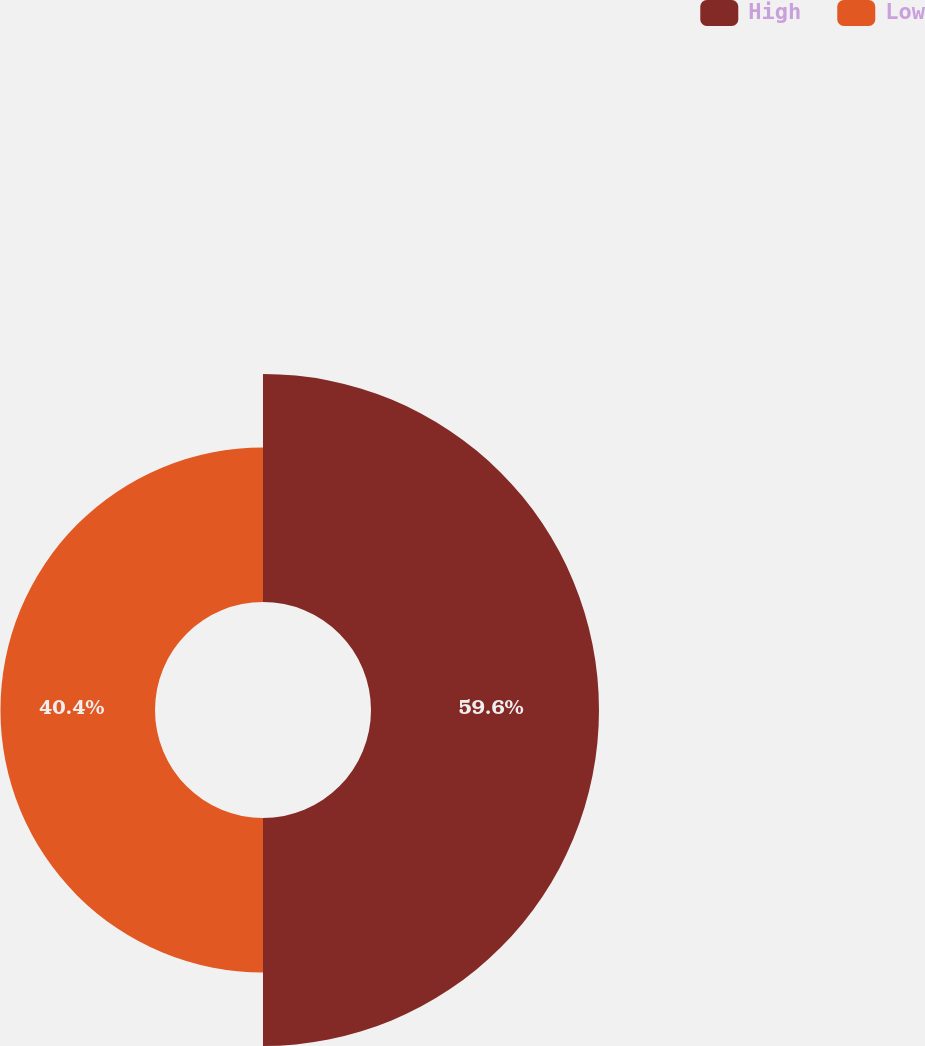Convert chart. <chart><loc_0><loc_0><loc_500><loc_500><pie_chart><fcel>High<fcel>Low<nl><fcel>59.6%<fcel>40.4%<nl></chart> 